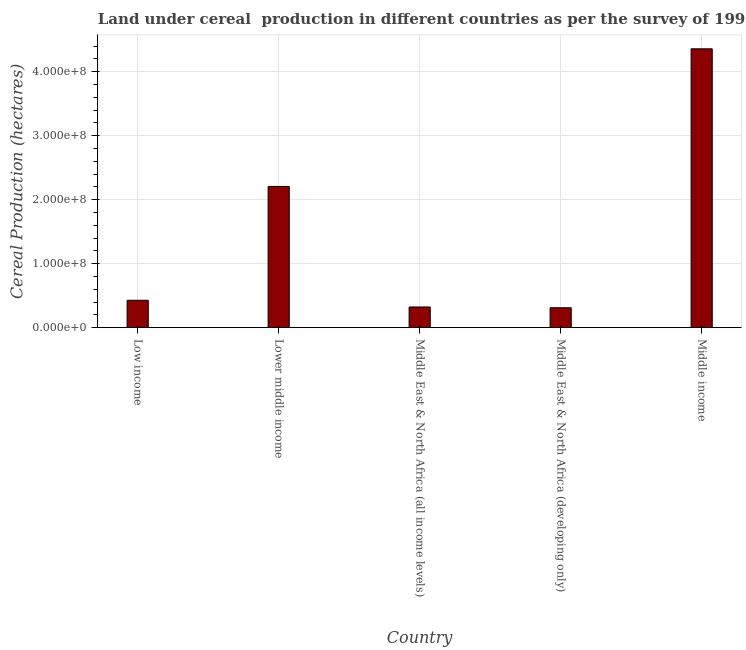Does the graph contain grids?
Offer a very short reply. Yes. What is the title of the graph?
Provide a short and direct response. Land under cereal  production in different countries as per the survey of 1992. What is the label or title of the X-axis?
Provide a succinct answer. Country. What is the label or title of the Y-axis?
Offer a terse response. Cereal Production (hectares). What is the land under cereal production in Middle East & North Africa (all income levels)?
Your answer should be compact. 3.23e+07. Across all countries, what is the maximum land under cereal production?
Offer a very short reply. 4.36e+08. Across all countries, what is the minimum land under cereal production?
Provide a short and direct response. 3.11e+07. In which country was the land under cereal production minimum?
Keep it short and to the point. Middle East & North Africa (developing only). What is the sum of the land under cereal production?
Make the answer very short. 7.63e+08. What is the difference between the land under cereal production in Low income and Lower middle income?
Offer a terse response. -1.78e+08. What is the average land under cereal production per country?
Your answer should be very brief. 1.53e+08. What is the median land under cereal production?
Your answer should be compact. 4.28e+07. In how many countries, is the land under cereal production greater than 180000000 hectares?
Provide a succinct answer. 2. What is the ratio of the land under cereal production in Low income to that in Middle East & North Africa (all income levels)?
Offer a very short reply. 1.32. Is the difference between the land under cereal production in Middle East & North Africa (all income levels) and Middle East & North Africa (developing only) greater than the difference between any two countries?
Offer a very short reply. No. What is the difference between the highest and the second highest land under cereal production?
Keep it short and to the point. 2.15e+08. Is the sum of the land under cereal production in Low income and Middle income greater than the maximum land under cereal production across all countries?
Keep it short and to the point. Yes. What is the difference between the highest and the lowest land under cereal production?
Offer a terse response. 4.05e+08. How many bars are there?
Provide a short and direct response. 5. Are the values on the major ticks of Y-axis written in scientific E-notation?
Offer a terse response. Yes. What is the Cereal Production (hectares) of Low income?
Your response must be concise. 4.28e+07. What is the Cereal Production (hectares) in Lower middle income?
Offer a very short reply. 2.21e+08. What is the Cereal Production (hectares) in Middle East & North Africa (all income levels)?
Your answer should be compact. 3.23e+07. What is the Cereal Production (hectares) of Middle East & North Africa (developing only)?
Provide a short and direct response. 3.11e+07. What is the Cereal Production (hectares) in Middle income?
Offer a very short reply. 4.36e+08. What is the difference between the Cereal Production (hectares) in Low income and Lower middle income?
Offer a terse response. -1.78e+08. What is the difference between the Cereal Production (hectares) in Low income and Middle East & North Africa (all income levels)?
Ensure brevity in your answer.  1.05e+07. What is the difference between the Cereal Production (hectares) in Low income and Middle East & North Africa (developing only)?
Your response must be concise. 1.17e+07. What is the difference between the Cereal Production (hectares) in Low income and Middle income?
Ensure brevity in your answer.  -3.93e+08. What is the difference between the Cereal Production (hectares) in Lower middle income and Middle East & North Africa (all income levels)?
Keep it short and to the point. 1.88e+08. What is the difference between the Cereal Production (hectares) in Lower middle income and Middle East & North Africa (developing only)?
Your answer should be compact. 1.90e+08. What is the difference between the Cereal Production (hectares) in Lower middle income and Middle income?
Your answer should be compact. -2.15e+08. What is the difference between the Cereal Production (hectares) in Middle East & North Africa (all income levels) and Middle East & North Africa (developing only)?
Your response must be concise. 1.23e+06. What is the difference between the Cereal Production (hectares) in Middle East & North Africa (all income levels) and Middle income?
Make the answer very short. -4.03e+08. What is the difference between the Cereal Production (hectares) in Middle East & North Africa (developing only) and Middle income?
Your answer should be compact. -4.05e+08. What is the ratio of the Cereal Production (hectares) in Low income to that in Lower middle income?
Provide a short and direct response. 0.19. What is the ratio of the Cereal Production (hectares) in Low income to that in Middle East & North Africa (all income levels)?
Give a very brief answer. 1.32. What is the ratio of the Cereal Production (hectares) in Low income to that in Middle East & North Africa (developing only)?
Make the answer very short. 1.38. What is the ratio of the Cereal Production (hectares) in Low income to that in Middle income?
Make the answer very short. 0.1. What is the ratio of the Cereal Production (hectares) in Lower middle income to that in Middle East & North Africa (all income levels)?
Give a very brief answer. 6.83. What is the ratio of the Cereal Production (hectares) in Lower middle income to that in Middle East & North Africa (developing only)?
Your response must be concise. 7.1. What is the ratio of the Cereal Production (hectares) in Lower middle income to that in Middle income?
Your answer should be compact. 0.51. What is the ratio of the Cereal Production (hectares) in Middle East & North Africa (all income levels) to that in Middle East & North Africa (developing only)?
Keep it short and to the point. 1.04. What is the ratio of the Cereal Production (hectares) in Middle East & North Africa (all income levels) to that in Middle income?
Keep it short and to the point. 0.07. What is the ratio of the Cereal Production (hectares) in Middle East & North Africa (developing only) to that in Middle income?
Give a very brief answer. 0.07. 